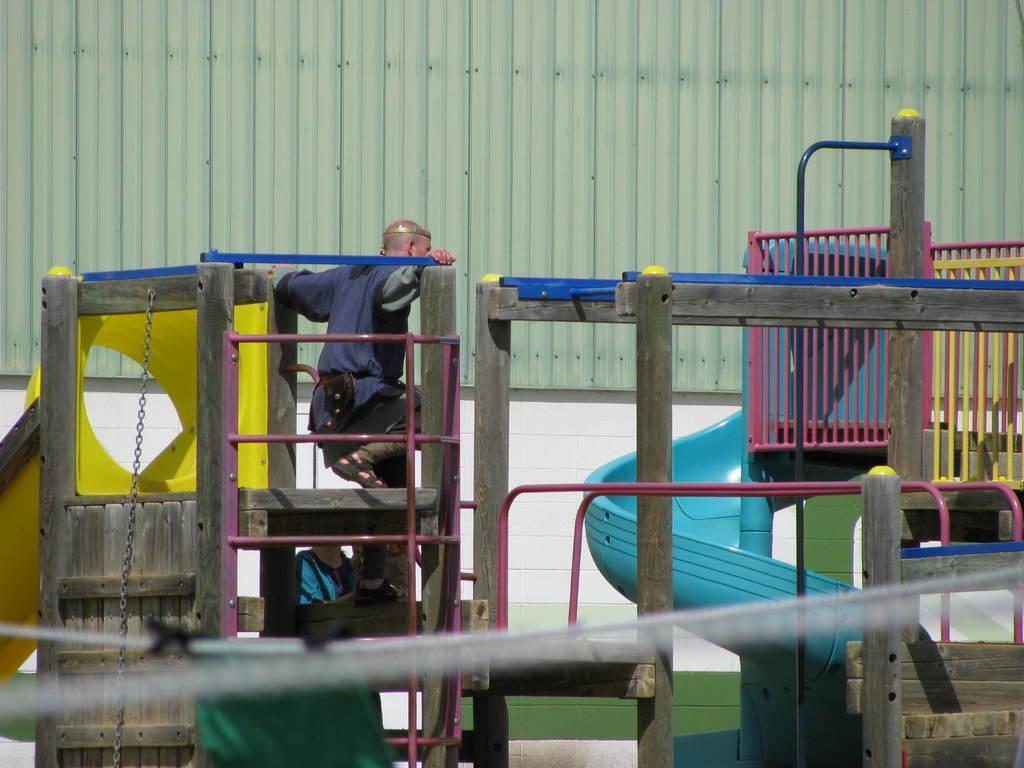How would you summarize this image in a sentence or two? Here we can see Kinder play equipment and there are two persons. In the background we can see wall. 